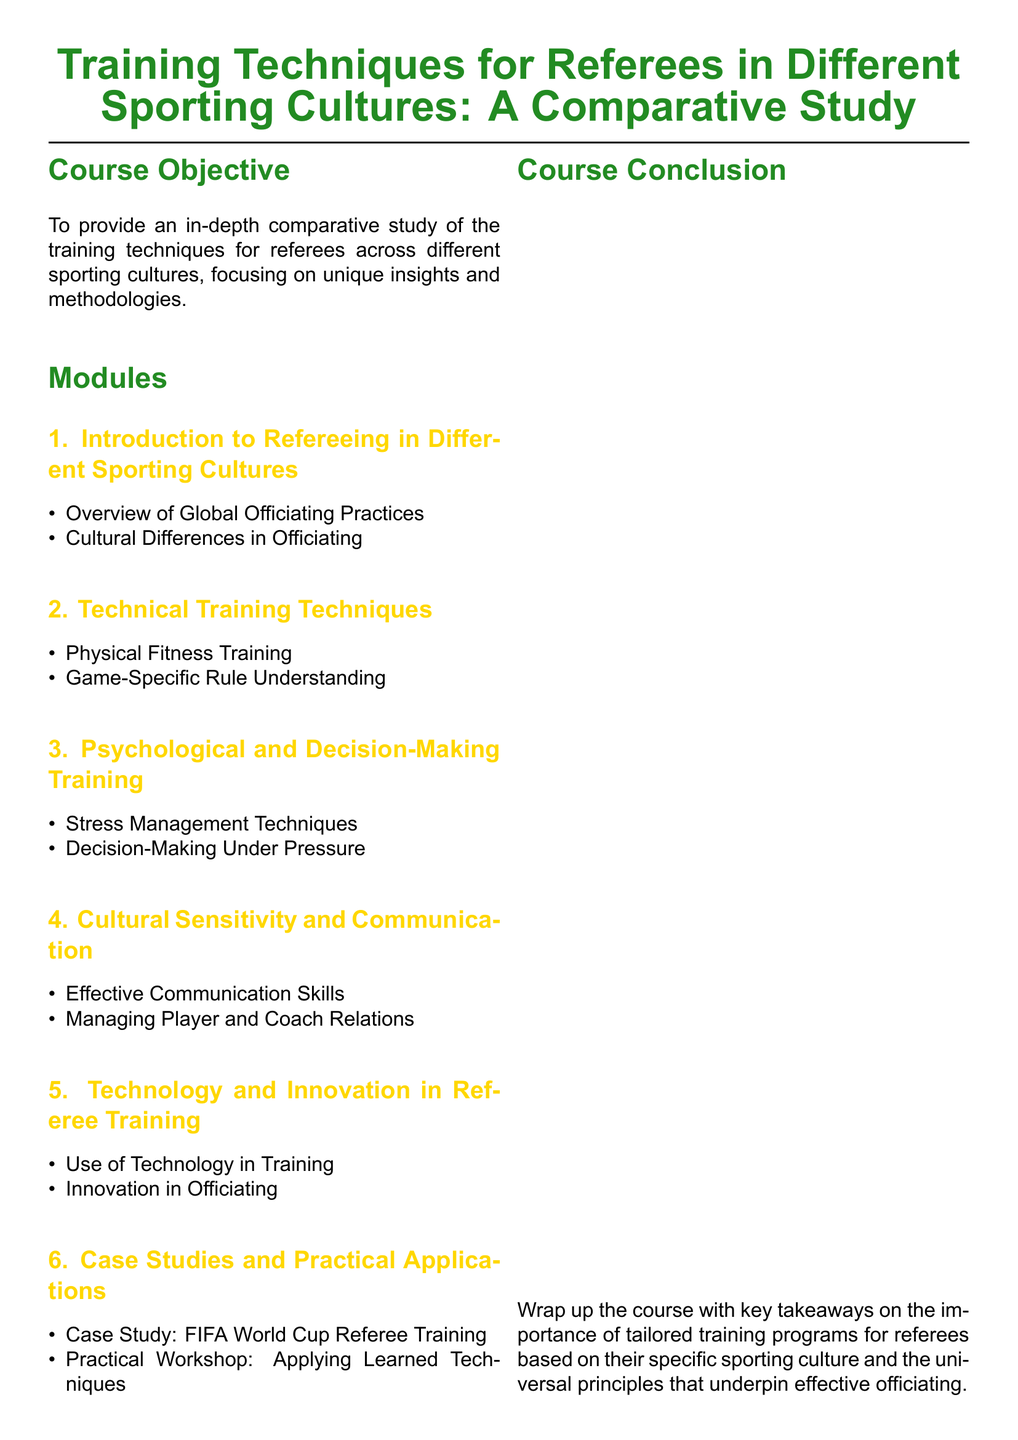What is the course objective? The course objective is stated in the document, which focuses on providing an in-depth comparative study of the training techniques for referees across different sporting cultures.
Answer: Comparative study of the training techniques for referees across different sporting cultures How many modules are there in the syllabus? The document lists six modules under the structure of the course, indicating the total number of modules available for study.
Answer: Six What is the title of Module 4? The title of Module 4 is explicitly listed in the document as part of the module descriptions, focusing on a specific aspect of referee training.
Answer: Cultural Sensitivity and Communication What training technique involves managing high-pressure situations? The document refers to specific training techniques under "Psychological and Decision-Making Training," which includes managing high-pressure situations.
Answer: Decision-Making Under Pressure Which sport's referees use mindfulness practices? The document mentions that mindfulness practices are discussed in relation to NBA referees, indicating a specific example of psychological training techniques.
Answer: NBA What technology is studied in Module 5? The syllabus outlines the use of technology in referee training, providing details on specific technologies covered in this module.
Answer: Video analysis tools What is essential for managing player and coach relations? The syllabus indicates that effective communication skills are crucial for managing relationships with players and coaches, highlighting an important aspect of officiating training.
Answer: Effective Communication Skills What is the focus of the case study in Module 6? The document specifies that the case study in Module 6 examines the FIFA World Cup referee training program, showcasing a practical aspect of the coursework.
Answer: FIFA World Cup Referee Training 